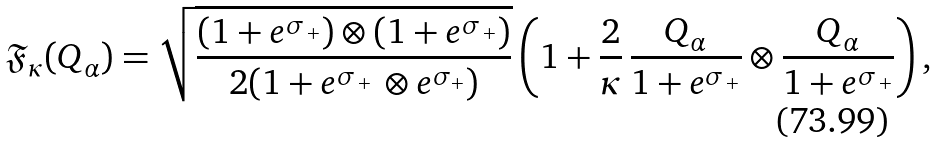<formula> <loc_0><loc_0><loc_500><loc_500>\mathfrak { F } _ { \kappa } ( Q _ { \alpha } ) = \sqrt { \frac { ( 1 + e ^ { \sigma _ { \, + } } ) \otimes ( 1 + e ^ { \sigma _ { \, + } } ) } { 2 ( 1 + e ^ { \sigma _ { \, + } } \, \otimes e ^ { \sigma _ { + } } ) } } \left ( 1 + \frac { 2 } { \kappa } \, \frac { Q _ { \alpha } } { 1 + e ^ { \sigma _ { \, + } } } \otimes \frac { Q _ { \alpha } } { 1 + e ^ { \sigma _ { \, + } } } \right ) ,</formula> 